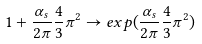Convert formula to latex. <formula><loc_0><loc_0><loc_500><loc_500>1 + \frac { \alpha _ { s } } { 2 \pi } \frac { 4 } { 3 } \pi ^ { 2 } \to e x p ( \frac { \alpha _ { s } } { 2 \pi } \frac { 4 } { 3 } \pi ^ { 2 } )</formula> 